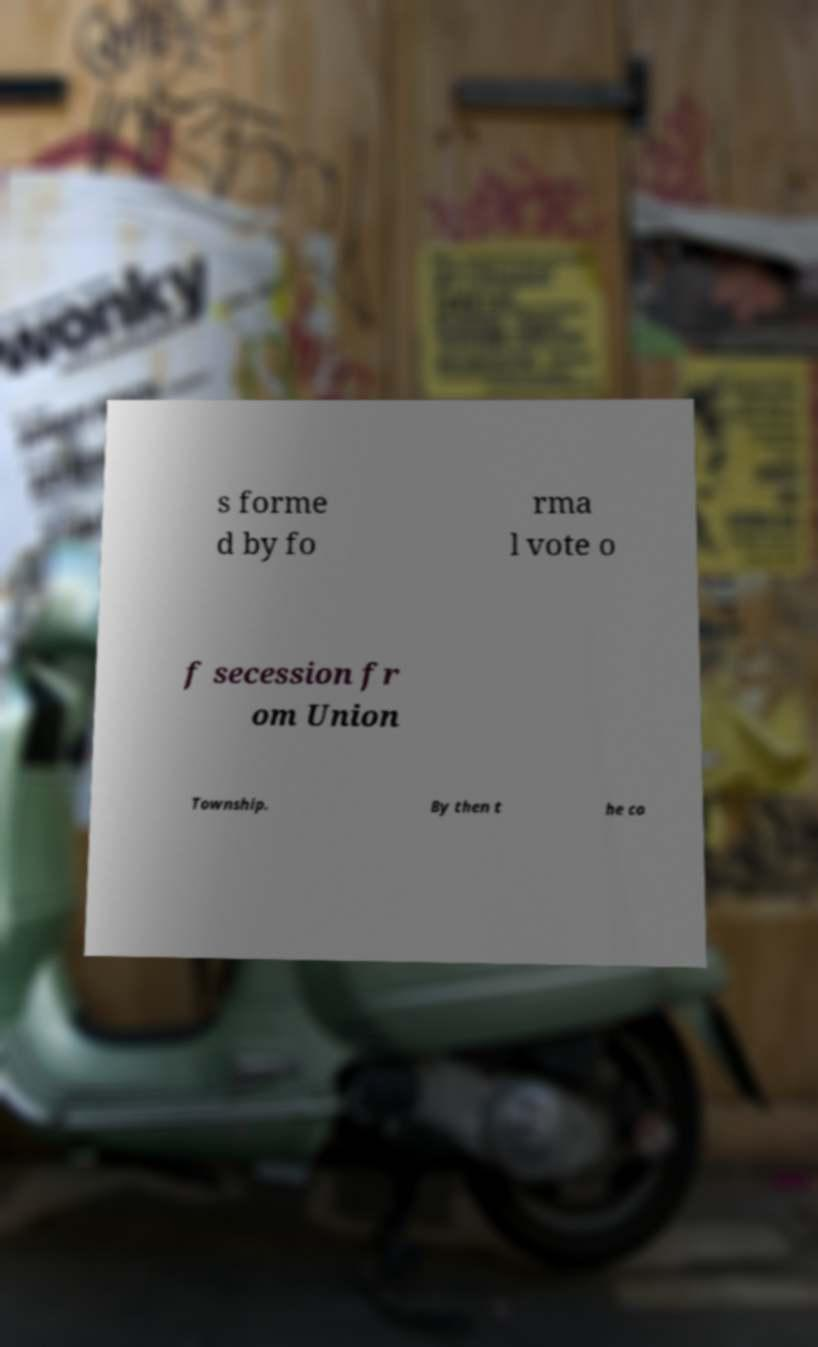Can you read and provide the text displayed in the image?This photo seems to have some interesting text. Can you extract and type it out for me? s forme d by fo rma l vote o f secession fr om Union Township. By then t he co 